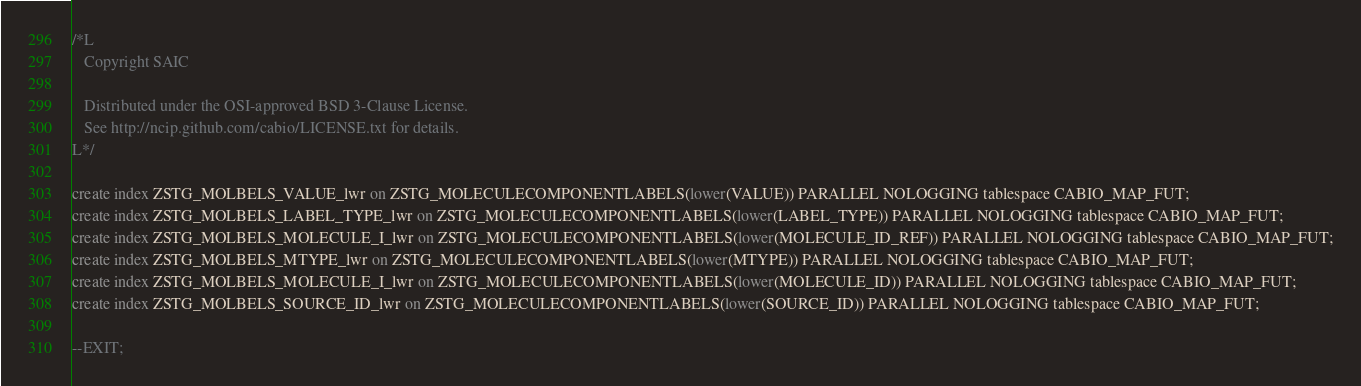<code> <loc_0><loc_0><loc_500><loc_500><_SQL_>/*L
   Copyright SAIC

   Distributed under the OSI-approved BSD 3-Clause License.
   See http://ncip.github.com/cabio/LICENSE.txt for details.
L*/

create index ZSTG_MOLBELS_VALUE_lwr on ZSTG_MOLECULECOMPONENTLABELS(lower(VALUE)) PARALLEL NOLOGGING tablespace CABIO_MAP_FUT;
create index ZSTG_MOLBELS_LABEL_TYPE_lwr on ZSTG_MOLECULECOMPONENTLABELS(lower(LABEL_TYPE)) PARALLEL NOLOGGING tablespace CABIO_MAP_FUT;
create index ZSTG_MOLBELS_MOLECULE_I_lwr on ZSTG_MOLECULECOMPONENTLABELS(lower(MOLECULE_ID_REF)) PARALLEL NOLOGGING tablespace CABIO_MAP_FUT;
create index ZSTG_MOLBELS_MTYPE_lwr on ZSTG_MOLECULECOMPONENTLABELS(lower(MTYPE)) PARALLEL NOLOGGING tablespace CABIO_MAP_FUT;
create index ZSTG_MOLBELS_MOLECULE_I_lwr on ZSTG_MOLECULECOMPONENTLABELS(lower(MOLECULE_ID)) PARALLEL NOLOGGING tablespace CABIO_MAP_FUT;
create index ZSTG_MOLBELS_SOURCE_ID_lwr on ZSTG_MOLECULECOMPONENTLABELS(lower(SOURCE_ID)) PARALLEL NOLOGGING tablespace CABIO_MAP_FUT;

--EXIT;
</code> 